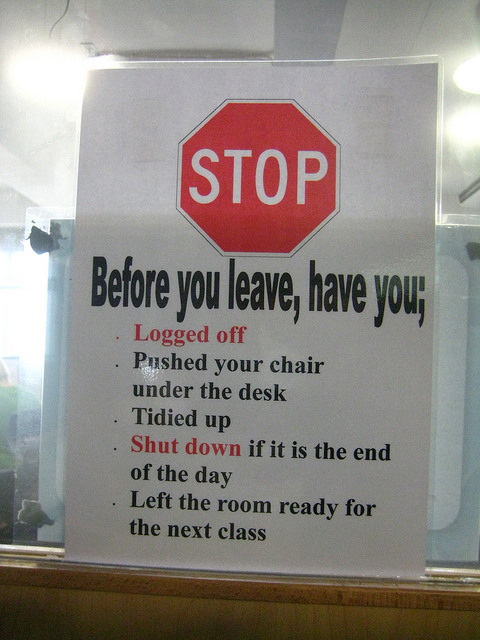Identify the text displayed in this image. STOP Before you leave, have you; the next class for ready room the Left day the of end the is it if down Shut up Tidied under the desk Pushed Your chair off Logged 